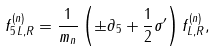Convert formula to latex. <formula><loc_0><loc_0><loc_500><loc_500>f ^ { ( n ) } _ { 5 \, { L , R } } = \frac { 1 } { m _ { n } } \left ( \pm \partial _ { 5 } + \frac { 1 } { 2 } \sigma ^ { \prime } \right ) f ^ { ( n ) } _ { L , R } ,</formula> 